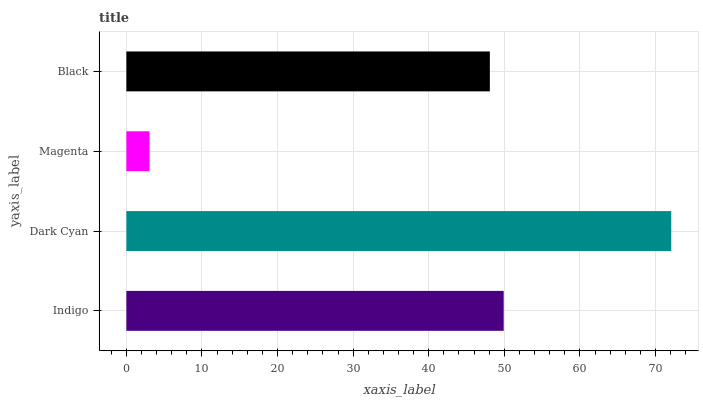Is Magenta the minimum?
Answer yes or no. Yes. Is Dark Cyan the maximum?
Answer yes or no. Yes. Is Dark Cyan the minimum?
Answer yes or no. No. Is Magenta the maximum?
Answer yes or no. No. Is Dark Cyan greater than Magenta?
Answer yes or no. Yes. Is Magenta less than Dark Cyan?
Answer yes or no. Yes. Is Magenta greater than Dark Cyan?
Answer yes or no. No. Is Dark Cyan less than Magenta?
Answer yes or no. No. Is Indigo the high median?
Answer yes or no. Yes. Is Black the low median?
Answer yes or no. Yes. Is Magenta the high median?
Answer yes or no. No. Is Magenta the low median?
Answer yes or no. No. 